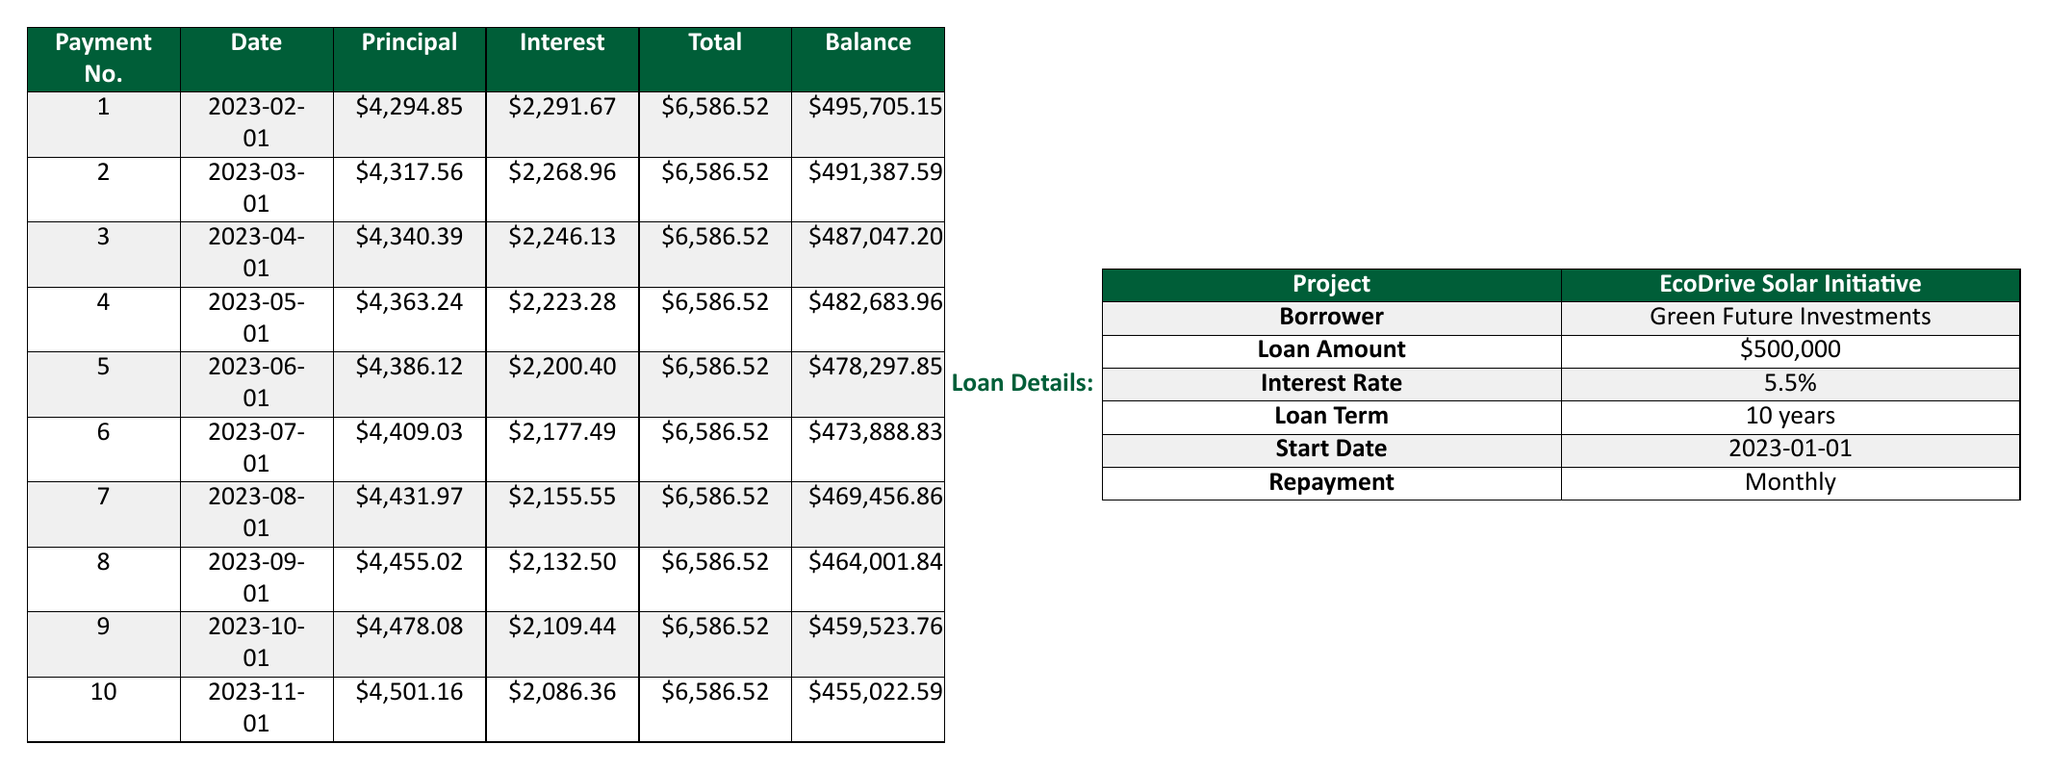What is the total amount paid in the first payment? The total payment for the first payment is listed in the table under the "Total" column for payment number 1, which is 6586.52.
Answer: 6586.52 How much of the first payment went towards the principal? From the table, the principal payment for the first payment, found in the "Principal" column for payment number 1, is 4294.85.
Answer: 4294.85 What is the remaining balance after the third payment? The remaining balance is found in the "Balance" column for payment number 3 in the table, which shows that the balance after the third payment is 487047.20.
Answer: 487047.20 Is the interest payment for the second payment less than that of the first payment? By comparing the interest payments in the "Interest" column, the first payment is 2291.67 and the second is 2268.96. Since 2268.96 is less than 2291.67, the answer is yes.
Answer: Yes What is the total principal paid after the first five payments? To find the total principal paid after the first five payments, add the principal payments from payment numbers 1 through 5: 4294.85 + 4317.56 + 4340.39 + 4363.24 + 4386.12 = 21662.16.
Answer: 21662.16 By how much does the principal payment increase by after the first payment? The principal payment for the first payment is 4294.85 and the second is 4317.56. The increase is 4317.56 - 4294.85 = 22.71.
Answer: 22.71 What is the average total payment over the first 10 months? To find the average, sum the total payments (which are all the same, 6586.52) for 10 months to get 6586.52 * 10 = 65865.20. Then divide by 10: 65865.20 / 10 = 6586.52.
Answer: 6586.52 Which payment has the highest interest payment, and what is that amount? By examining the "Interest" column, you can see the amounts for each payment. The highest interest payment is found in the first payment at 2291.67.
Answer: 2291.67 What is the total remaining balance after ten payments? The remaining balance after ten payments can be found in the "Balance" column for payment number 10, which shows an outstanding balance of 455022.59.
Answer: 455022.59 